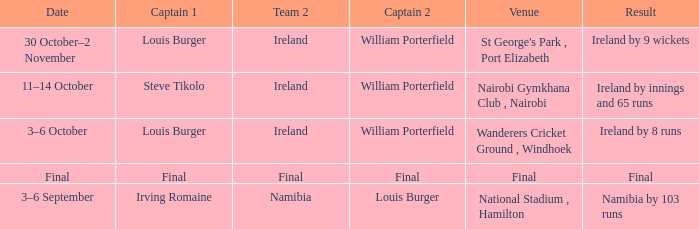I'm looking to parse the entire table for insights. Could you assist me with that? {'header': ['Date', 'Captain 1', 'Team 2', 'Captain 2', 'Venue', 'Result'], 'rows': [['30 October–2 November', 'Louis Burger', 'Ireland', 'William Porterfield', "St George's Park , Port Elizabeth", 'Ireland by 9 wickets'], ['11–14 October', 'Steve Tikolo', 'Ireland', 'William Porterfield', 'Nairobi Gymkhana Club , Nairobi', 'Ireland by innings and 65 runs'], ['3–6 October', 'Louis Burger', 'Ireland', 'William Porterfield', 'Wanderers Cricket Ground , Windhoek', 'Ireland by 8 runs'], ['Final', 'Final', 'Final', 'Final', 'Final', 'Final'], ['3–6 September', 'Irving Romaine', 'Namibia', 'Louis Burger', 'National Stadium , Hamilton', 'Namibia by 103 runs']]} Which Team 2 has a Captain 1 of final? Final. 